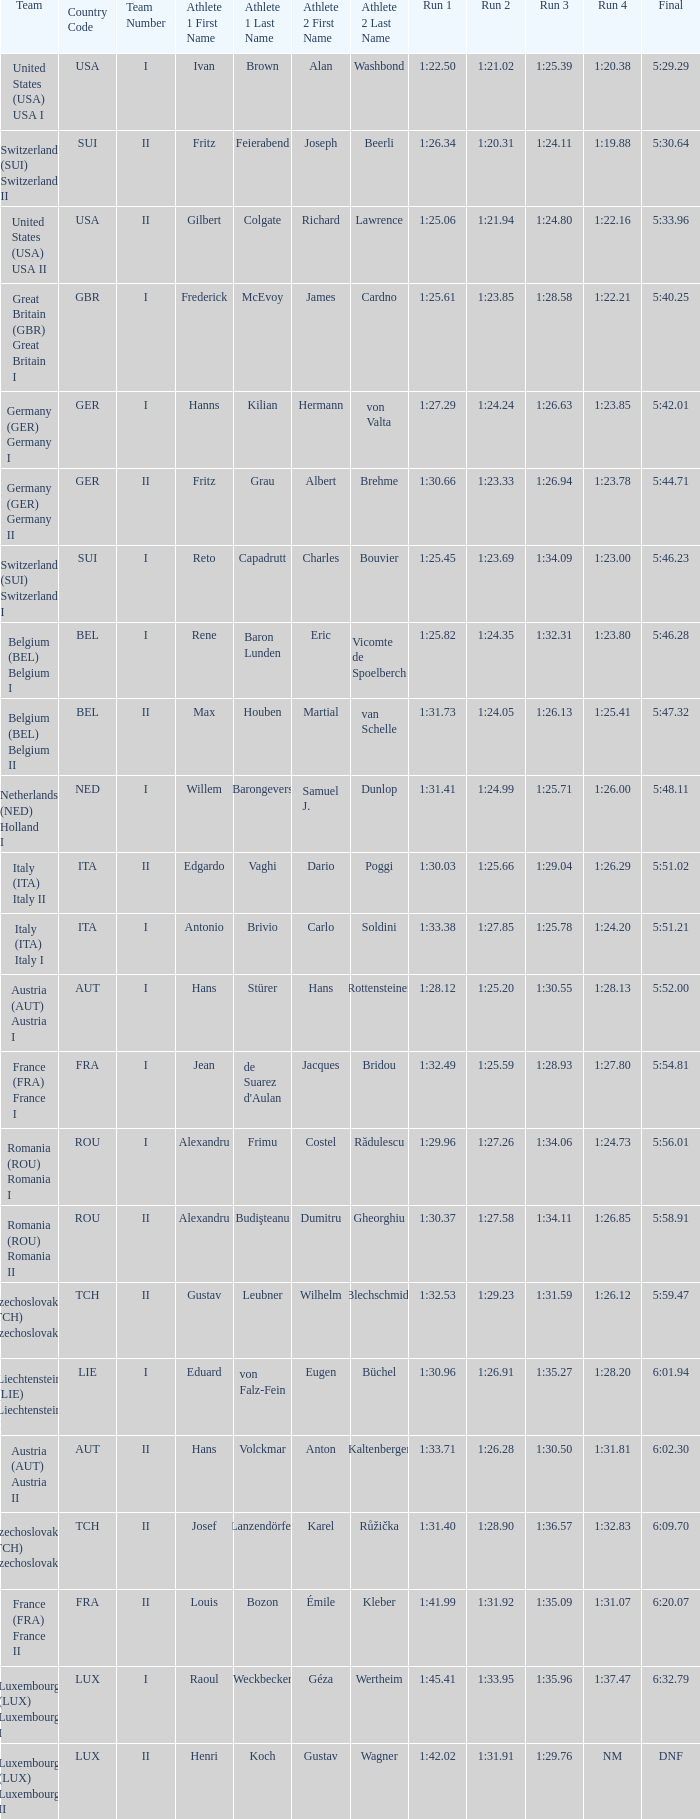Which run 4 has a run 3 time of 1:2 1:23.85. 